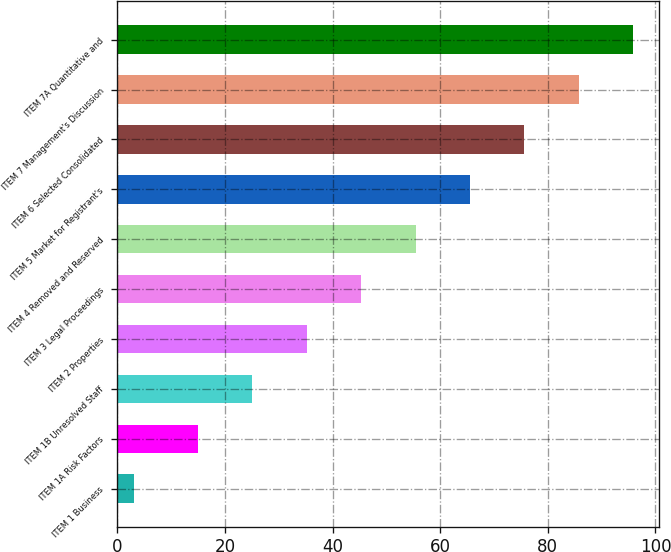<chart> <loc_0><loc_0><loc_500><loc_500><bar_chart><fcel>ITEM 1 Business<fcel>ITEM 1A Risk Factors<fcel>ITEM 1B Unresolved Staff<fcel>ITEM 2 Properties<fcel>ITEM 3 Legal Proceedings<fcel>ITEM 4 Removed and Reserved<fcel>ITEM 5 Market for Registrant's<fcel>ITEM 6 Selected Consolidated<fcel>ITEM 7 Management's Discussion<fcel>ITEM 7A Quantitative and<nl><fcel>3<fcel>15<fcel>25.1<fcel>35.2<fcel>45.3<fcel>55.4<fcel>65.5<fcel>75.6<fcel>85.7<fcel>95.8<nl></chart> 